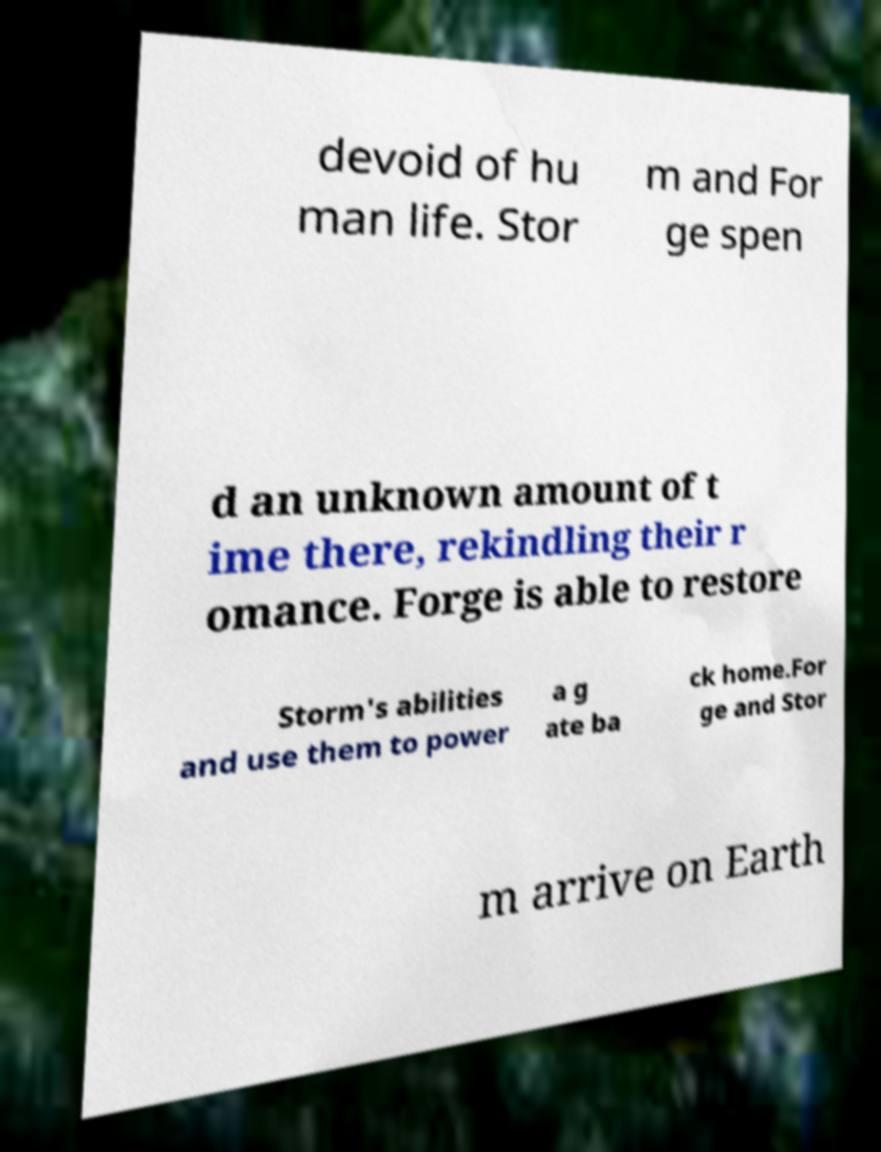I need the written content from this picture converted into text. Can you do that? devoid of hu man life. Stor m and For ge spen d an unknown amount of t ime there, rekindling their r omance. Forge is able to restore Storm's abilities and use them to power a g ate ba ck home.For ge and Stor m arrive on Earth 